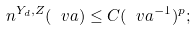<formula> <loc_0><loc_0><loc_500><loc_500>n ^ { Y _ { d } , Z } ( \ v a ) \leq C ( \ v a ^ { - 1 } ) ^ { p } ;</formula> 